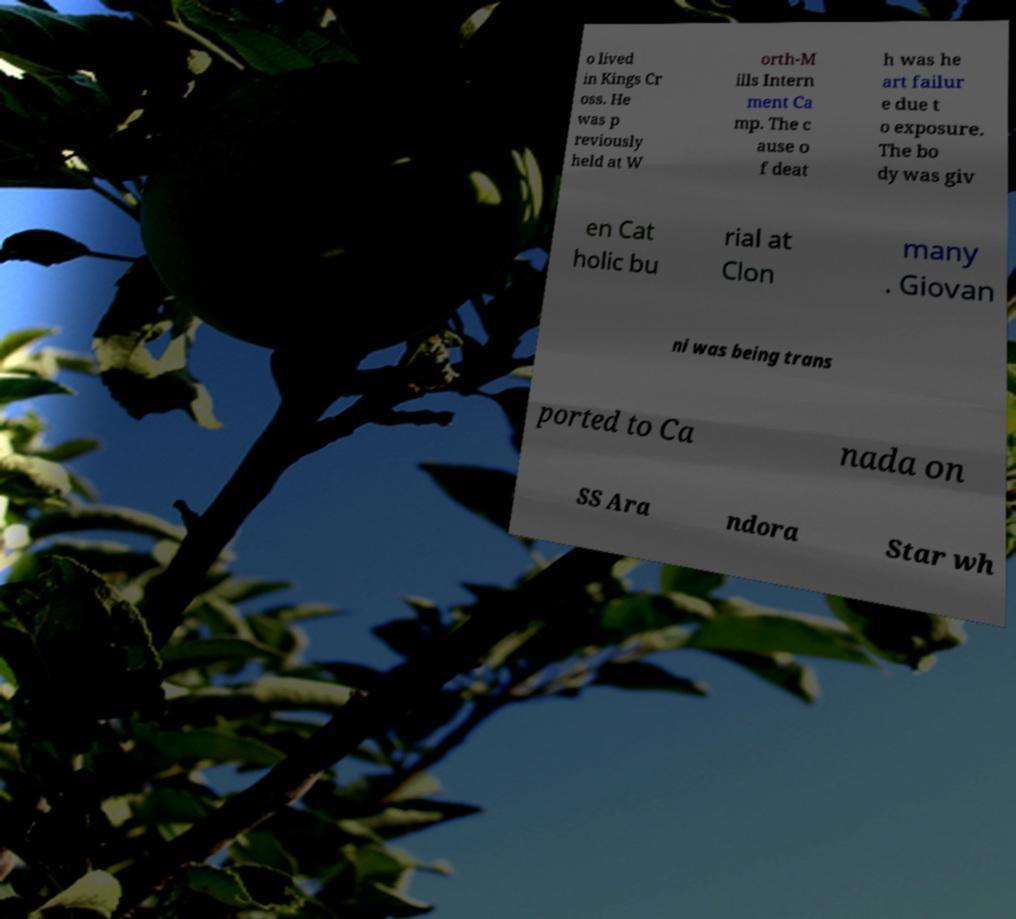Please read and relay the text visible in this image. What does it say? o lived in Kings Cr oss. He was p reviously held at W orth-M ills Intern ment Ca mp. The c ause o f deat h was he art failur e due t o exposure. The bo dy was giv en Cat holic bu rial at Clon many . Giovan ni was being trans ported to Ca nada on SS Ara ndora Star wh 